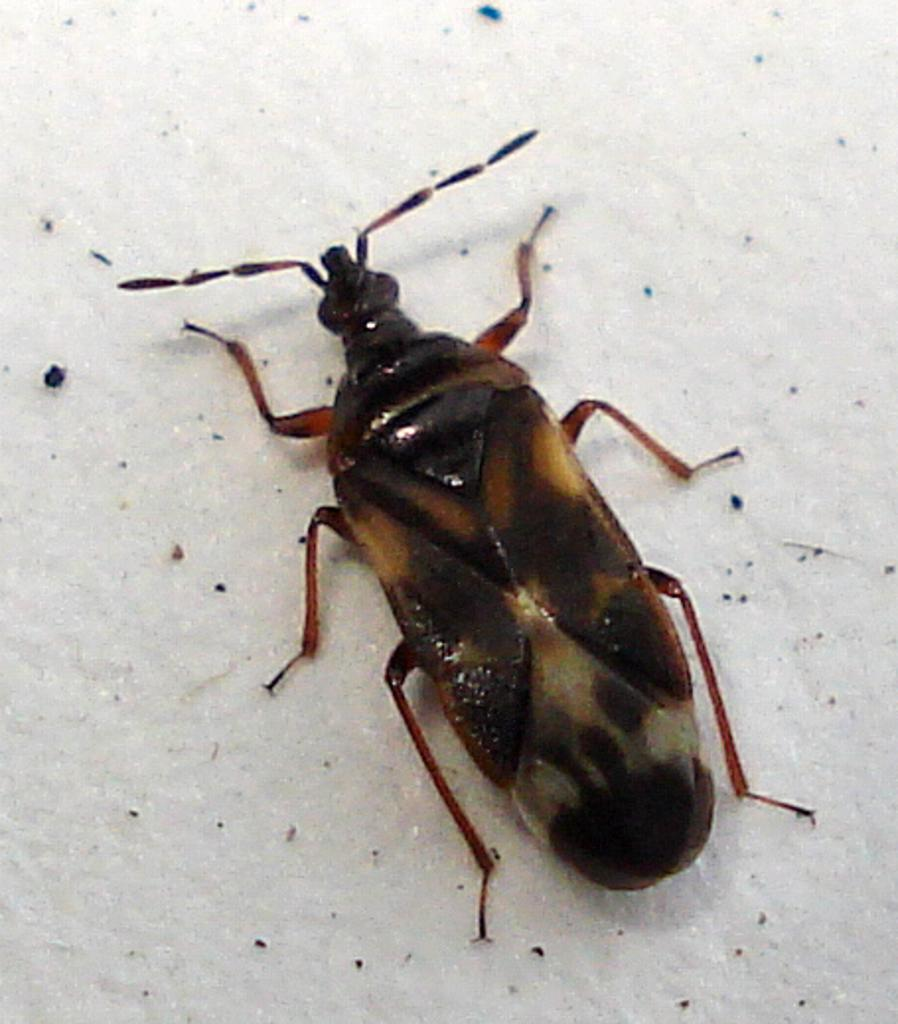What type of creature is present in the image? There is an insect in the image. Where is the insect located in the image? The insect is on a surface. What type of shop can be seen in the image? There is no shop present in the image; it features an insect on a surface. How does the insect perform a trick in the image? The insect does not perform a trick in the image; it is simply located on a surface. 